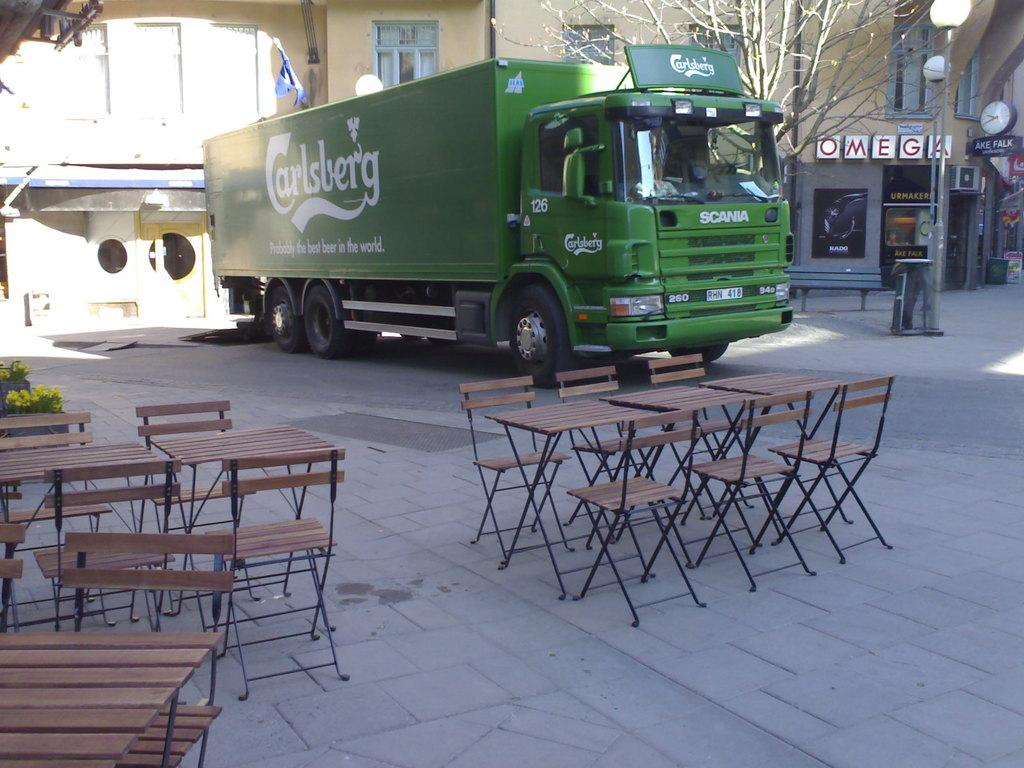What is the main vehicle visible in the image? There is a truck in the image. What type of structure is also present in the image? There is a house in the image. What type of furniture can be seen in the image? There are chairs and tables in the image. What type of plant is visible in the image? There is a tree in the image. What type of polish is being applied to the chairs in the image? There is no indication in the image that any polish is being applied to the chairs. What innovative idea is being discussed at the table in the image? There is no indication in the image that any discussion or idea is taking place at the table. 